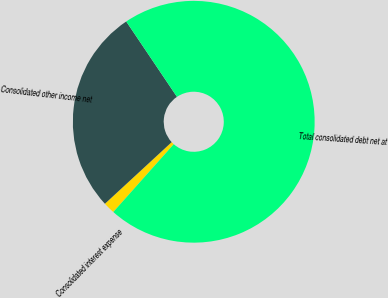Convert chart. <chart><loc_0><loc_0><loc_500><loc_500><pie_chart><fcel>Consolidated interest expense<fcel>Consolidated other income net<fcel>Total consolidated debt net at<nl><fcel>1.55%<fcel>27.43%<fcel>71.02%<nl></chart> 